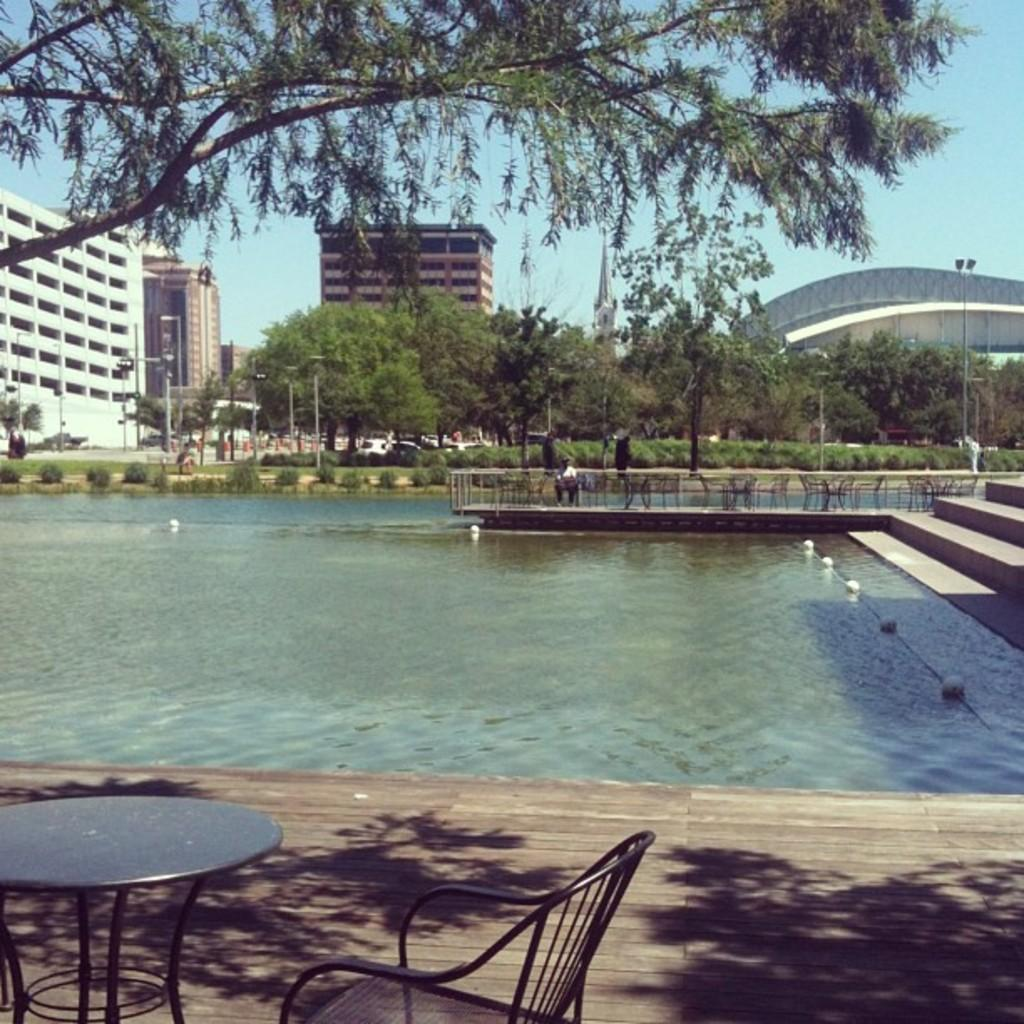What type of furniture is present in the image? There is a table and a chair in the image. Where are the table and chair located? The table and chair are in the left corner of the image. What can be seen in the image besides the table and chair? There is water visible in the image, as well as trees and buildings in the background. What color is the poison that is visible in the image? There is no poison present in the image. 